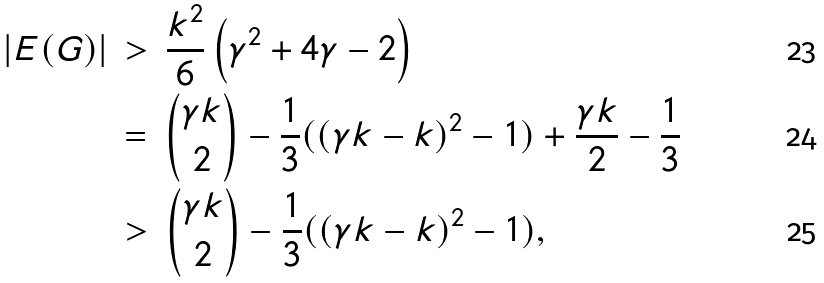<formula> <loc_0><loc_0><loc_500><loc_500>| E ( G ) | & \, > \, \frac { k ^ { 2 } } { 6 } \left ( \gamma ^ { 2 } + 4 \gamma - 2 \right ) \\ & \, = \, { \gamma k \choose 2 } - \frac { 1 } { 3 } ( ( \gamma k - k ) ^ { 2 } - 1 ) + \frac { \gamma k } { 2 } - \frac { 1 } { 3 } \\ & \, > \, { \gamma k \choose 2 } - \frac { 1 } { 3 } ( ( \gamma k - k ) ^ { 2 } - 1 ) ,</formula> 